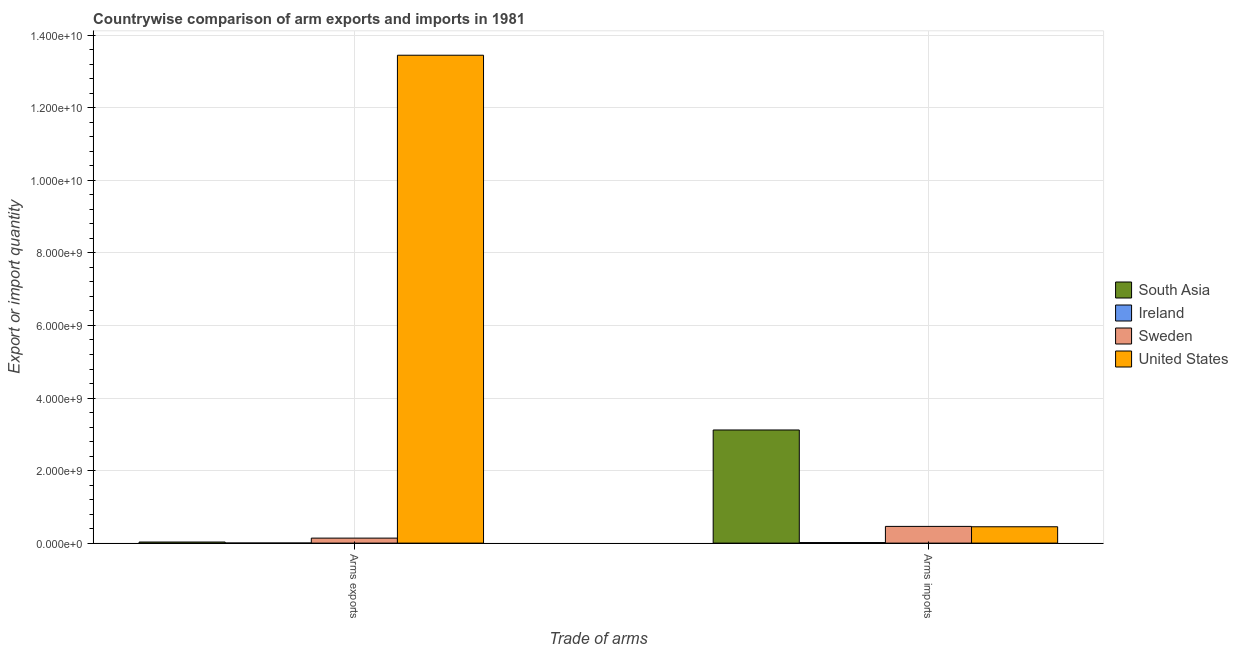How many different coloured bars are there?
Your answer should be very brief. 4. How many groups of bars are there?
Offer a terse response. 2. Are the number of bars per tick equal to the number of legend labels?
Give a very brief answer. Yes. How many bars are there on the 1st tick from the left?
Offer a very short reply. 4. How many bars are there on the 2nd tick from the right?
Offer a very short reply. 4. What is the label of the 2nd group of bars from the left?
Your answer should be compact. Arms imports. What is the arms imports in Sweden?
Give a very brief answer. 4.61e+08. Across all countries, what is the maximum arms exports?
Your response must be concise. 1.35e+1. Across all countries, what is the minimum arms exports?
Provide a succinct answer. 2.00e+06. In which country was the arms imports maximum?
Provide a short and direct response. South Asia. In which country was the arms imports minimum?
Make the answer very short. Ireland. What is the total arms imports in the graph?
Offer a terse response. 4.05e+09. What is the difference between the arms imports in South Asia and that in United States?
Your answer should be very brief. 2.67e+09. What is the difference between the arms imports in South Asia and the arms exports in Ireland?
Keep it short and to the point. 3.12e+09. What is the average arms imports per country?
Your answer should be compact. 1.01e+09. What is the difference between the arms imports and arms exports in Sweden?
Make the answer very short. 3.23e+08. In how many countries, is the arms imports greater than 6800000000 ?
Your answer should be very brief. 0. What is the ratio of the arms exports in Ireland to that in South Asia?
Provide a short and direct response. 0.07. What does the 4th bar from the right in Arms imports represents?
Ensure brevity in your answer.  South Asia. How many bars are there?
Give a very brief answer. 8. Are the values on the major ticks of Y-axis written in scientific E-notation?
Your answer should be compact. Yes. Does the graph contain grids?
Your answer should be very brief. Yes. What is the title of the graph?
Offer a very short reply. Countrywise comparison of arm exports and imports in 1981. What is the label or title of the X-axis?
Give a very brief answer. Trade of arms. What is the label or title of the Y-axis?
Your response must be concise. Export or import quantity. What is the Export or import quantity of South Asia in Arms exports?
Your response must be concise. 3.00e+07. What is the Export or import quantity of Ireland in Arms exports?
Provide a short and direct response. 2.00e+06. What is the Export or import quantity in Sweden in Arms exports?
Your answer should be compact. 1.38e+08. What is the Export or import quantity of United States in Arms exports?
Offer a very short reply. 1.35e+1. What is the Export or import quantity in South Asia in Arms imports?
Provide a short and direct response. 3.12e+09. What is the Export or import quantity in Ireland in Arms imports?
Offer a terse response. 1.50e+07. What is the Export or import quantity of Sweden in Arms imports?
Provide a succinct answer. 4.61e+08. What is the Export or import quantity in United States in Arms imports?
Your answer should be very brief. 4.51e+08. Across all Trade of arms, what is the maximum Export or import quantity of South Asia?
Provide a succinct answer. 3.12e+09. Across all Trade of arms, what is the maximum Export or import quantity of Ireland?
Offer a very short reply. 1.50e+07. Across all Trade of arms, what is the maximum Export or import quantity in Sweden?
Ensure brevity in your answer.  4.61e+08. Across all Trade of arms, what is the maximum Export or import quantity of United States?
Provide a short and direct response. 1.35e+1. Across all Trade of arms, what is the minimum Export or import quantity of South Asia?
Offer a terse response. 3.00e+07. Across all Trade of arms, what is the minimum Export or import quantity of Sweden?
Provide a succinct answer. 1.38e+08. Across all Trade of arms, what is the minimum Export or import quantity of United States?
Your response must be concise. 4.51e+08. What is the total Export or import quantity in South Asia in the graph?
Provide a succinct answer. 3.15e+09. What is the total Export or import quantity of Ireland in the graph?
Your response must be concise. 1.70e+07. What is the total Export or import quantity in Sweden in the graph?
Your response must be concise. 5.99e+08. What is the total Export or import quantity of United States in the graph?
Offer a very short reply. 1.39e+1. What is the difference between the Export or import quantity in South Asia in Arms exports and that in Arms imports?
Ensure brevity in your answer.  -3.09e+09. What is the difference between the Export or import quantity of Ireland in Arms exports and that in Arms imports?
Provide a succinct answer. -1.30e+07. What is the difference between the Export or import quantity of Sweden in Arms exports and that in Arms imports?
Make the answer very short. -3.23e+08. What is the difference between the Export or import quantity in United States in Arms exports and that in Arms imports?
Your response must be concise. 1.30e+1. What is the difference between the Export or import quantity of South Asia in Arms exports and the Export or import quantity of Ireland in Arms imports?
Your answer should be very brief. 1.50e+07. What is the difference between the Export or import quantity in South Asia in Arms exports and the Export or import quantity in Sweden in Arms imports?
Your response must be concise. -4.31e+08. What is the difference between the Export or import quantity in South Asia in Arms exports and the Export or import quantity in United States in Arms imports?
Give a very brief answer. -4.21e+08. What is the difference between the Export or import quantity of Ireland in Arms exports and the Export or import quantity of Sweden in Arms imports?
Give a very brief answer. -4.59e+08. What is the difference between the Export or import quantity of Ireland in Arms exports and the Export or import quantity of United States in Arms imports?
Provide a succinct answer. -4.49e+08. What is the difference between the Export or import quantity of Sweden in Arms exports and the Export or import quantity of United States in Arms imports?
Provide a short and direct response. -3.13e+08. What is the average Export or import quantity of South Asia per Trade of arms?
Your response must be concise. 1.57e+09. What is the average Export or import quantity of Ireland per Trade of arms?
Give a very brief answer. 8.50e+06. What is the average Export or import quantity of Sweden per Trade of arms?
Your response must be concise. 3.00e+08. What is the average Export or import quantity in United States per Trade of arms?
Offer a terse response. 6.95e+09. What is the difference between the Export or import quantity of South Asia and Export or import quantity of Ireland in Arms exports?
Make the answer very short. 2.80e+07. What is the difference between the Export or import quantity of South Asia and Export or import quantity of Sweden in Arms exports?
Your answer should be very brief. -1.08e+08. What is the difference between the Export or import quantity in South Asia and Export or import quantity in United States in Arms exports?
Ensure brevity in your answer.  -1.34e+1. What is the difference between the Export or import quantity of Ireland and Export or import quantity of Sweden in Arms exports?
Your answer should be very brief. -1.36e+08. What is the difference between the Export or import quantity of Ireland and Export or import quantity of United States in Arms exports?
Provide a short and direct response. -1.34e+1. What is the difference between the Export or import quantity of Sweden and Export or import quantity of United States in Arms exports?
Offer a terse response. -1.33e+1. What is the difference between the Export or import quantity in South Asia and Export or import quantity in Ireland in Arms imports?
Your answer should be compact. 3.10e+09. What is the difference between the Export or import quantity of South Asia and Export or import quantity of Sweden in Arms imports?
Provide a succinct answer. 2.66e+09. What is the difference between the Export or import quantity of South Asia and Export or import quantity of United States in Arms imports?
Provide a succinct answer. 2.67e+09. What is the difference between the Export or import quantity of Ireland and Export or import quantity of Sweden in Arms imports?
Keep it short and to the point. -4.46e+08. What is the difference between the Export or import quantity of Ireland and Export or import quantity of United States in Arms imports?
Give a very brief answer. -4.36e+08. What is the ratio of the Export or import quantity of South Asia in Arms exports to that in Arms imports?
Your answer should be very brief. 0.01. What is the ratio of the Export or import quantity of Ireland in Arms exports to that in Arms imports?
Offer a terse response. 0.13. What is the ratio of the Export or import quantity of Sweden in Arms exports to that in Arms imports?
Ensure brevity in your answer.  0.3. What is the ratio of the Export or import quantity in United States in Arms exports to that in Arms imports?
Keep it short and to the point. 29.82. What is the difference between the highest and the second highest Export or import quantity in South Asia?
Your answer should be very brief. 3.09e+09. What is the difference between the highest and the second highest Export or import quantity of Ireland?
Ensure brevity in your answer.  1.30e+07. What is the difference between the highest and the second highest Export or import quantity in Sweden?
Make the answer very short. 3.23e+08. What is the difference between the highest and the second highest Export or import quantity in United States?
Keep it short and to the point. 1.30e+1. What is the difference between the highest and the lowest Export or import quantity of South Asia?
Provide a succinct answer. 3.09e+09. What is the difference between the highest and the lowest Export or import quantity of Ireland?
Ensure brevity in your answer.  1.30e+07. What is the difference between the highest and the lowest Export or import quantity of Sweden?
Offer a terse response. 3.23e+08. What is the difference between the highest and the lowest Export or import quantity of United States?
Offer a very short reply. 1.30e+1. 